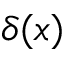<formula> <loc_0><loc_0><loc_500><loc_500>\delta ( x )</formula> 